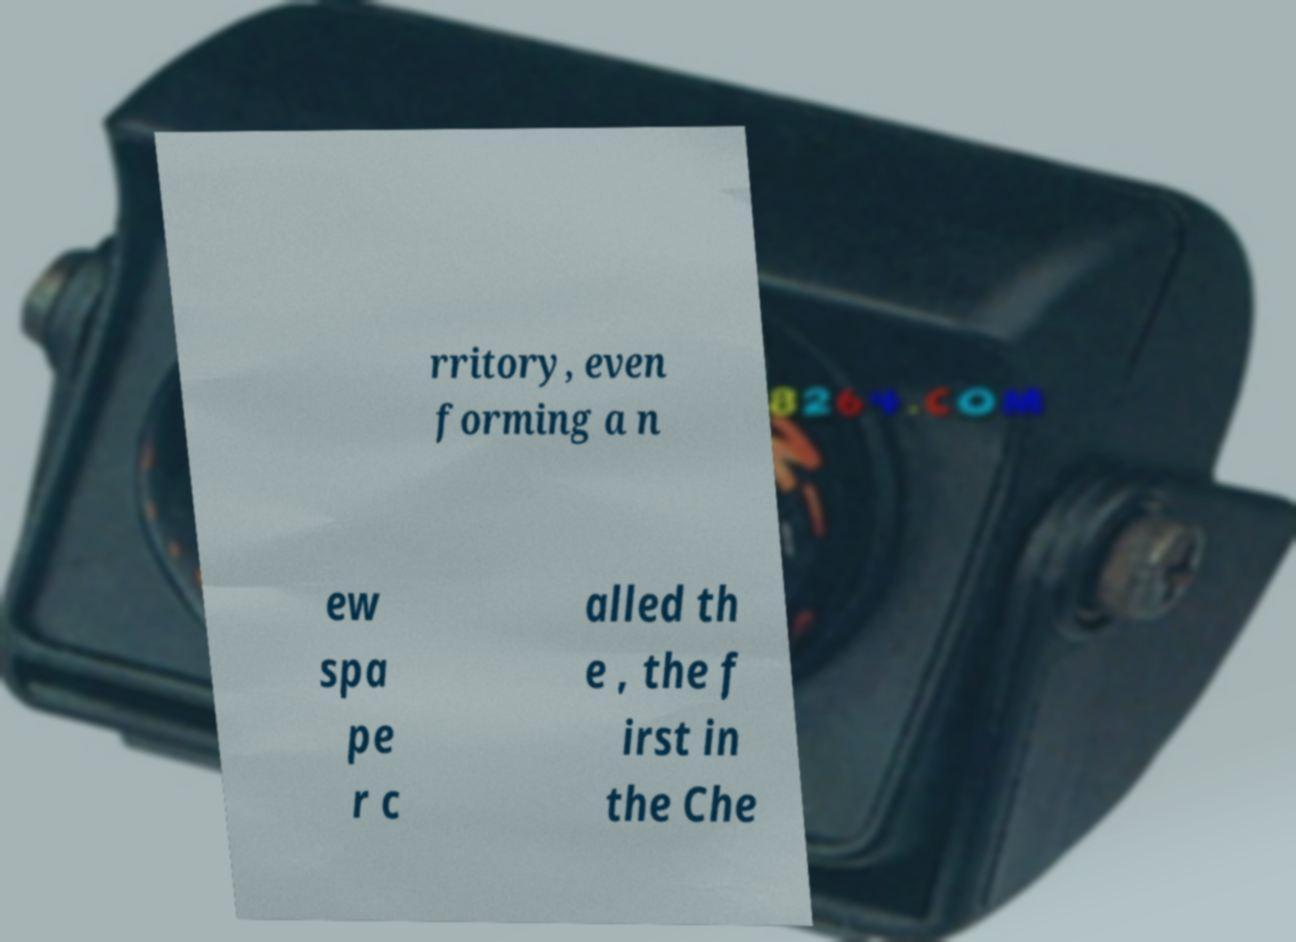What messages or text are displayed in this image? I need them in a readable, typed format. rritory, even forming a n ew spa pe r c alled th e , the f irst in the Che 